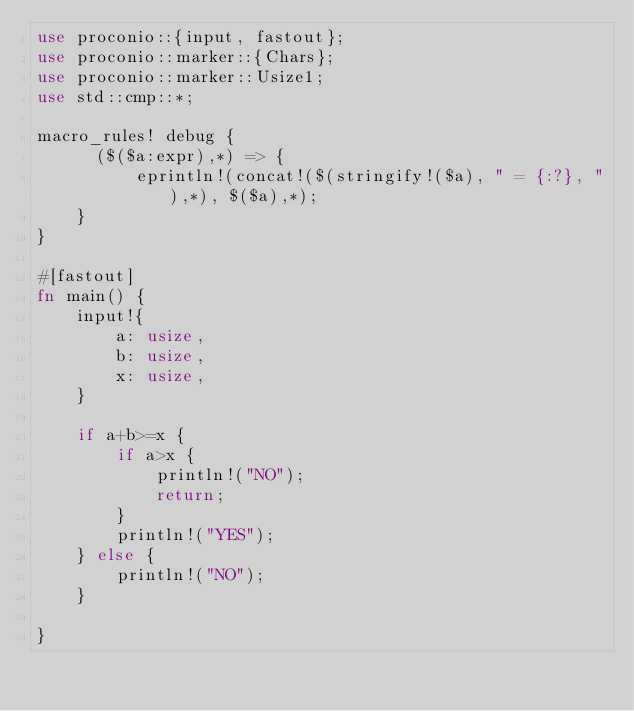<code> <loc_0><loc_0><loc_500><loc_500><_Rust_>use proconio::{input, fastout};
use proconio::marker::{Chars};
use proconio::marker::Usize1;
use std::cmp::*;

macro_rules! debug {
      ($($a:expr),*) => {
          eprintln!(concat!($(stringify!($a), " = {:?}, "),*), $($a),*);
    }
}

#[fastout]
fn main() {
    input!{
        a: usize,
        b: usize,
        x: usize,
    }

    if a+b>=x {
        if a>x {
            println!("NO");
            return;
        }
        println!("YES");
    } else {
        println!("NO");
    }

}
</code> 